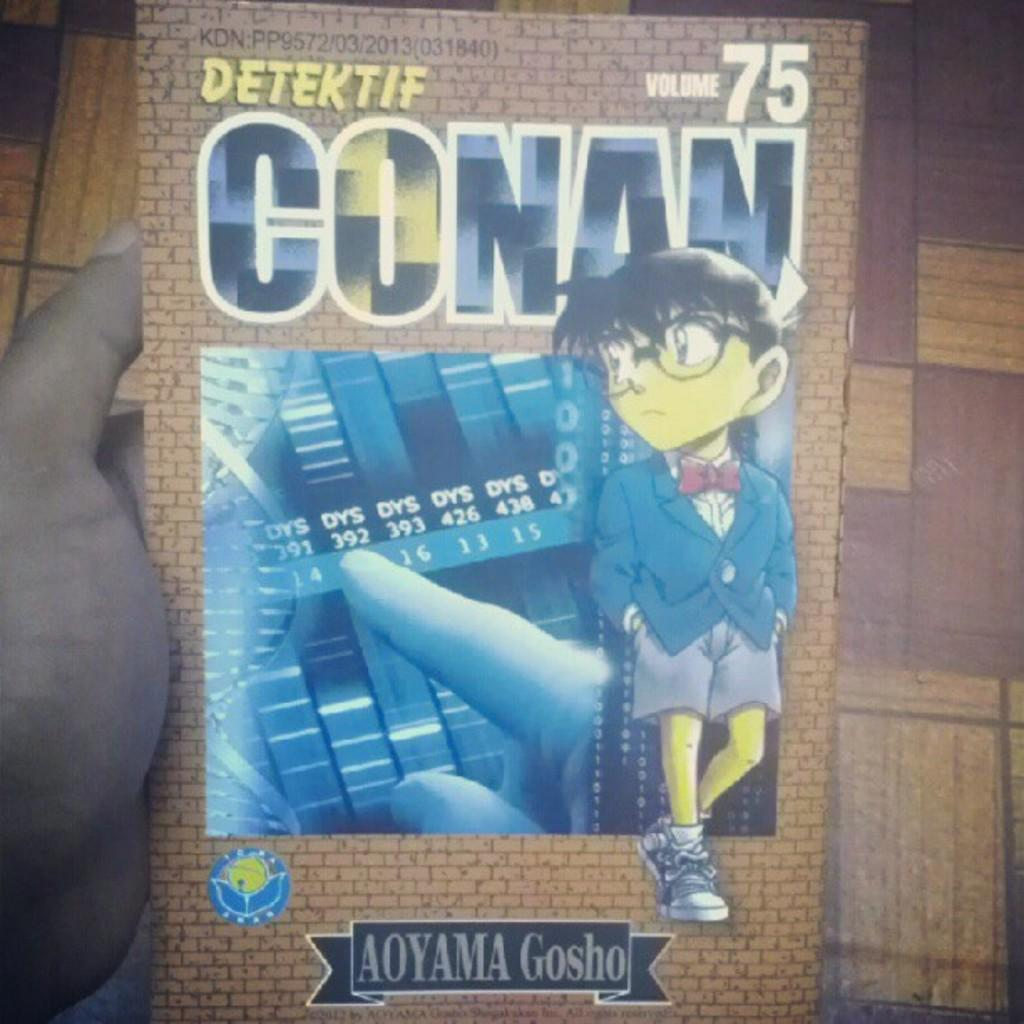<image>
Present a compact description of the photo's key features. A hand holding Volume 75 of the book Detektif Conan. 